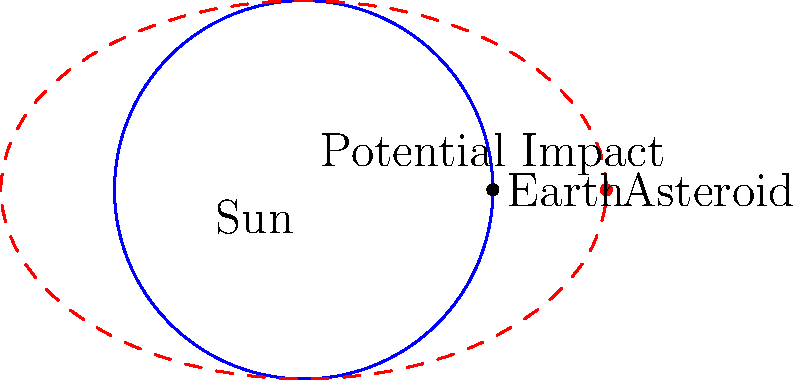Based on the orbital diagram, which represents a potential asteroid impact scenario, how might the depicted situation affect global biodiversity if the impact were to occur? Consider the implications for international wildlife protection efforts. To analyze the potential consequences of the asteroid impact on global biodiversity and international wildlife protection efforts, let's consider the following steps:

1. Impact location: The diagram shows a potential impact point where the asteroid's orbit intersects with Earth's orbit. This suggests a direct collision scenario.

2. Asteroid size: While not explicitly shown, the asteroid's elliptical orbit implies it could be a large Near-Earth Object (NEO), potentially several kilometers in diameter.

3. Immediate effects:
   a) Massive explosion upon impact, releasing energy equivalent to millions of nuclear bombs.
   b) Global dust cloud, blocking sunlight and potentially triggering a "nuclear winter" effect.
   c) Widespread fires and earthquakes.

4. Short-term consequences:
   a) Destruction of habitats in the impact zone and surrounding areas.
   b) Disruption of food chains due to plant death from lack of sunlight.
   c) Acid rain from vaporized rock and resulting chemical reactions in the atmosphere.

5. Long-term effects on biodiversity:
   a) Mass extinction event, potentially rivaling the K-T extinction that wiped out the dinosaurs.
   b) Loss of numerous species, especially those already vulnerable or with limited geographic distribution.
   c) Disruption of ecosystems and ecosystem services on a global scale.

6. Implications for international wildlife protection:
   a) Existing protected areas and conservation efforts may be rendered ineffective.
   b) Need for rapid reassessment of conservation priorities and strategies.
   c) Increased importance of preserving genetic diversity and establishing seed banks.
   d) Necessity for new international agreements focusing on post-impact recovery and habitat restoration.

7. Challenges for treaty negotiations:
   a) Urgency to develop international protocols for asteroid detection and deflection.
   b) Need for agreements on sharing resources and expertise for post-impact wildlife recovery.
   c) Potential conflicts between immediate human needs and long-term biodiversity conservation goals.

The scenario depicted would likely result in a catastrophic loss of biodiversity, necessitating a complete overhaul of existing wildlife protection treaties and the creation of new, more comprehensive international agreements to address the unprecedented challenges of post-impact conservation and ecosystem restoration.
Answer: Mass extinction event requiring new global conservation strategies and treaties 